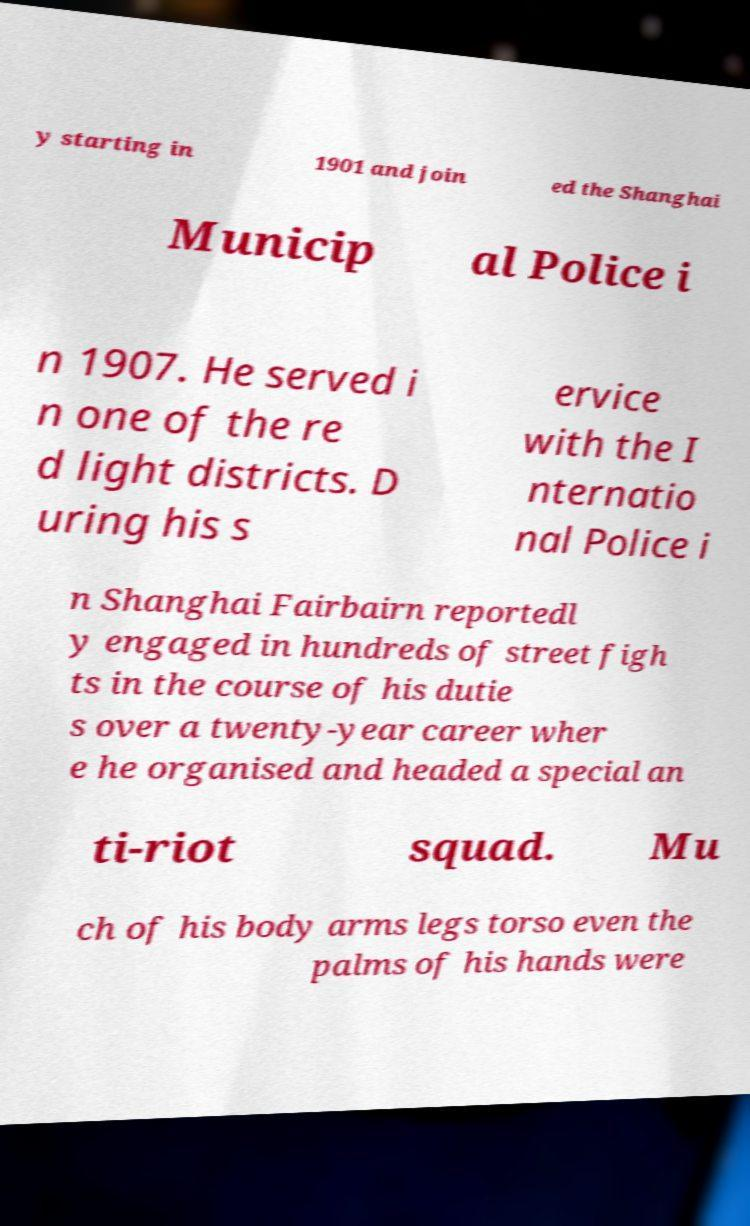Could you extract and type out the text from this image? y starting in 1901 and join ed the Shanghai Municip al Police i n 1907. He served i n one of the re d light districts. D uring his s ervice with the I nternatio nal Police i n Shanghai Fairbairn reportedl y engaged in hundreds of street figh ts in the course of his dutie s over a twenty-year career wher e he organised and headed a special an ti-riot squad. Mu ch of his body arms legs torso even the palms of his hands were 